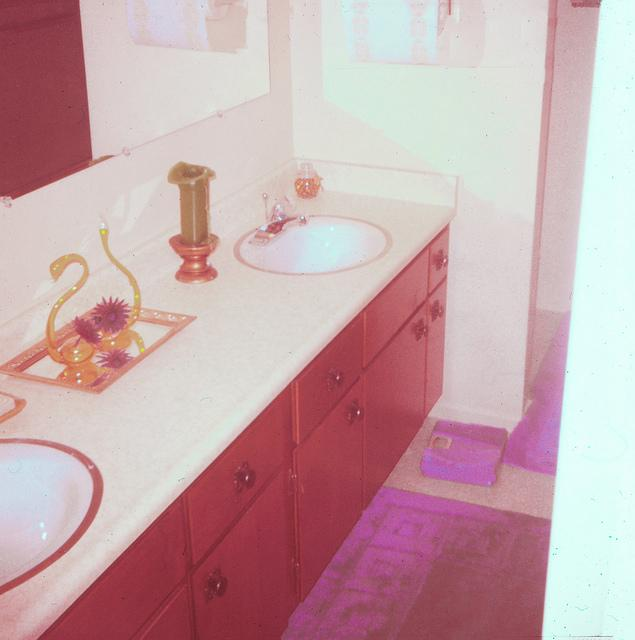What item on the counter has melted? candle 